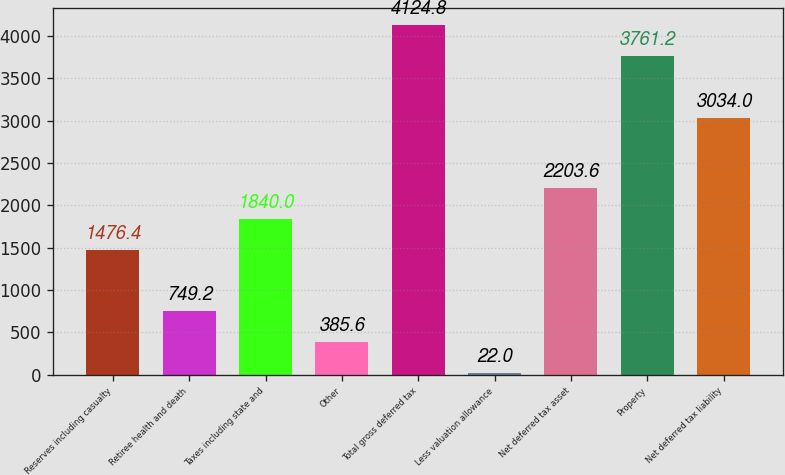<chart> <loc_0><loc_0><loc_500><loc_500><bar_chart><fcel>Reserves including casualty<fcel>Retiree health and death<fcel>Taxes including state and<fcel>Other<fcel>Total gross deferred tax<fcel>Less valuation allowance<fcel>Net deferred tax asset<fcel>Property<fcel>Net deferred tax liability<nl><fcel>1476.4<fcel>749.2<fcel>1840<fcel>385.6<fcel>4124.8<fcel>22<fcel>2203.6<fcel>3761.2<fcel>3034<nl></chart> 